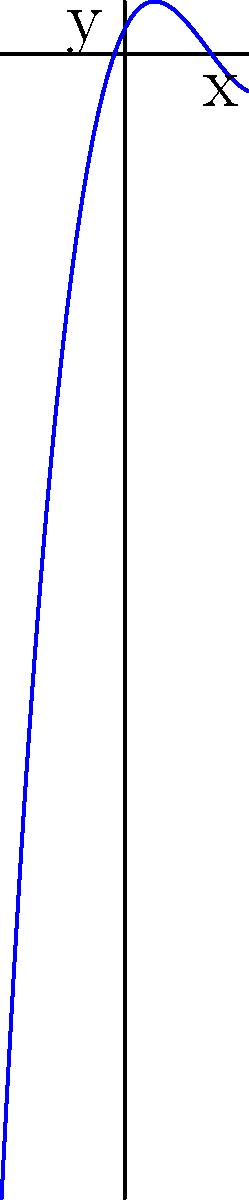Given the polynomial function $f(x) = 0.1x^3 - x^2 + 2x + 1$, what is the behavior of the function as $x$ approaches positive infinity? Analyze the graph and determine the dominant term that influences this behavior. To determine the behavior of the polynomial function as $x$ approaches positive infinity, we need to follow these steps:

1. Identify the degree of the polynomial:
   $f(x) = 0.1x^3 - x^2 + 2x + 1$ is a cubic polynomial (degree 3)

2. Identify the leading term:
   The leading term is $0.1x^3$

3. Analyze the leading term:
   - The coefficient is positive (0.1)
   - The degree is odd (3)

4. Apply the rule for polynomial behavior:
   - For odd-degree polynomials with a positive leading coefficient, as $x$ approaches positive infinity, $f(x)$ will approach positive infinity

5. Observe the graph:
   The graph shows the function increasing rapidly as $x$ increases, confirming our analysis

6. Conclusion:
   As $x$ approaches positive infinity, $f(x)$ will approach positive infinity, and this behavior is dominated by the $0.1x^3$ term
Answer: Approaches positive infinity, dominated by $0.1x^3$ term 